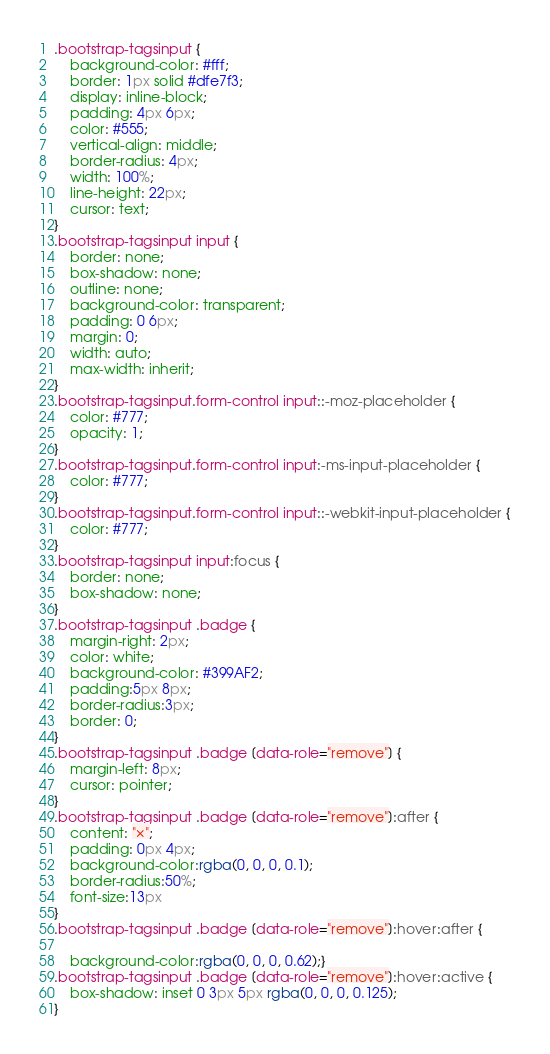Convert code to text. <code><loc_0><loc_0><loc_500><loc_500><_CSS_>
.bootstrap-tagsinput {
    background-color: #fff;
    border: 1px solid #dfe7f3;
    display: inline-block;
    padding: 4px 6px;
    color: #555;
    vertical-align: middle;
    border-radius: 4px;
    width: 100%;
    line-height: 22px;
    cursor: text;
}
.bootstrap-tagsinput input {
    border: none;
    box-shadow: none;
    outline: none;
    background-color: transparent;
    padding: 0 6px;
    margin: 0;
    width: auto;
    max-width: inherit;
}
.bootstrap-tagsinput.form-control input::-moz-placeholder {
    color: #777;
    opacity: 1;
}
.bootstrap-tagsinput.form-control input:-ms-input-placeholder {
    color: #777;
}
.bootstrap-tagsinput.form-control input::-webkit-input-placeholder {
    color: #777;
}
.bootstrap-tagsinput input:focus {
    border: none;
    box-shadow: none;
}
.bootstrap-tagsinput .badge {
    margin-right: 2px;
    color: white;
    background-color: #399AF2;
    padding:5px 8px;
    border-radius:3px;
    border: 0;
}
.bootstrap-tagsinput .badge [data-role="remove"] {
    margin-left: 8px;
    cursor: pointer;
}
.bootstrap-tagsinput .badge [data-role="remove"]:after {
    content: "×";
    padding: 0px 4px;
    background-color:rgba(0, 0, 0, 0.1);
    border-radius:50%;
    font-size:13px
}
.bootstrap-tagsinput .badge [data-role="remove"]:hover:after {

    background-color:rgba(0, 0, 0, 0.62);}
.bootstrap-tagsinput .badge [data-role="remove"]:hover:active {
    box-shadow: inset 0 3px 5px rgba(0, 0, 0, 0.125);
}
</code> 